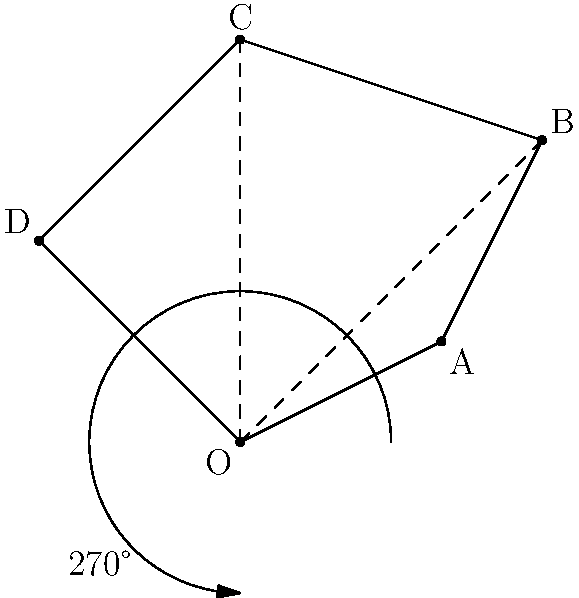A map of Victoria's hidden trails is represented by the polygon ABCD, with point O as the central point. If the map is rotated 270° counterclockwise around point O, what will be the new coordinates of point B after the rotation? To solve this problem, we'll follow these steps:

1) The original coordinates of point B are (3,3).

2) To rotate a point (x,y) by an angle θ counterclockwise around the origin, we use the rotation matrix:
   $$ \begin{pmatrix} \cos θ & -\sin θ \\ \sin θ & \cos θ \end{pmatrix} $$

3) For a 270° rotation, θ = 270° = 3π/2 radians. We can simplify:
   $\cos(270°) = 0$
   $\sin(270°) = -1$

4) Our rotation matrix becomes:
   $$ \begin{pmatrix} 0 & 1 \\ -1 & 0 \end{pmatrix} $$

5) We multiply this matrix by the coordinates of B:
   $$ \begin{pmatrix} 0 & 1 \\ -1 & 0 \end{pmatrix} \begin{pmatrix} 3 \\ 3 \end{pmatrix} = \begin{pmatrix} 3 \\ -3 \end{pmatrix} $$

6) Therefore, after rotation, the coordinates of B will be (3, -3).
Answer: (3, -3) 